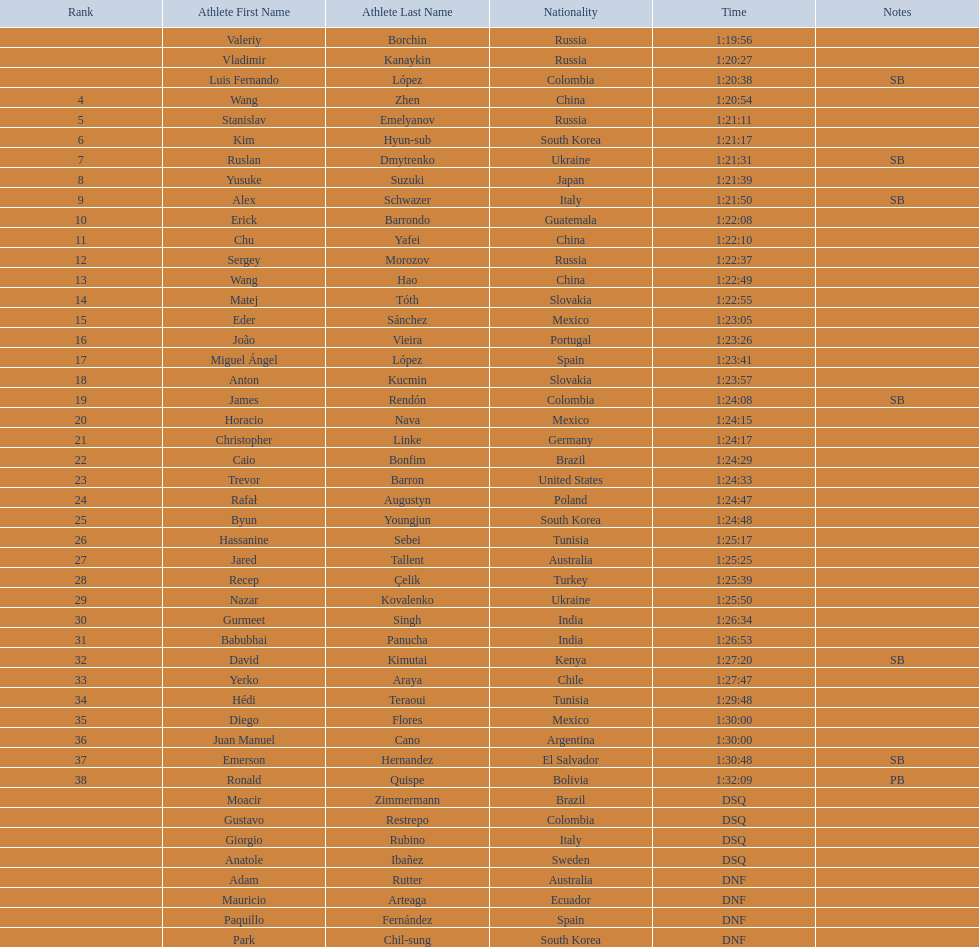Who placed in the top spot? Valeriy Borchin. Would you mind parsing the complete table? {'header': ['Rank', 'Athlete First Name', 'Athlete Last Name', 'Nationality', 'Time', 'Notes'], 'rows': [['', 'Valeriy', 'Borchin', 'Russia', '1:19:56', ''], ['', 'Vladimir', 'Kanaykin', 'Russia', '1:20:27', ''], ['', 'Luis Fernando', 'López', 'Colombia', '1:20:38', 'SB'], ['4', 'Wang', 'Zhen', 'China', '1:20:54', ''], ['5', 'Stanislav', 'Emelyanov', 'Russia', '1:21:11', ''], ['6', 'Kim', 'Hyun-sub', 'South Korea', '1:21:17', ''], ['7', 'Ruslan', 'Dmytrenko', 'Ukraine', '1:21:31', 'SB'], ['8', 'Yusuke', 'Suzuki', 'Japan', '1:21:39', ''], ['9', 'Alex', 'Schwazer', 'Italy', '1:21:50', 'SB'], ['10', 'Erick', 'Barrondo', 'Guatemala', '1:22:08', ''], ['11', 'Chu', 'Yafei', 'China', '1:22:10', ''], ['12', 'Sergey', 'Morozov', 'Russia', '1:22:37', ''], ['13', 'Wang', 'Hao', 'China', '1:22:49', ''], ['14', 'Matej', 'Tóth', 'Slovakia', '1:22:55', ''], ['15', 'Eder', 'Sánchez', 'Mexico', '1:23:05', ''], ['16', 'João', 'Vieira', 'Portugal', '1:23:26', ''], ['17', 'Miguel Ángel', 'López', 'Spain', '1:23:41', ''], ['18', 'Anton', 'Kucmin', 'Slovakia', '1:23:57', ''], ['19', 'James', 'Rendón', 'Colombia', '1:24:08', 'SB'], ['20', 'Horacio', 'Nava', 'Mexico', '1:24:15', ''], ['21', 'Christopher', 'Linke', 'Germany', '1:24:17', ''], ['22', 'Caio', 'Bonfim', 'Brazil', '1:24:29', ''], ['23', 'Trevor', 'Barron', 'United States', '1:24:33', ''], ['24', 'Rafał', 'Augustyn', 'Poland', '1:24:47', ''], ['25', 'Byun', 'Youngjun', 'South Korea', '1:24:48', ''], ['26', 'Hassanine', 'Sebei', 'Tunisia', '1:25:17', ''], ['27', 'Jared', 'Tallent', 'Australia', '1:25:25', ''], ['28', 'Recep', 'Çelik', 'Turkey', '1:25:39', ''], ['29', 'Nazar', 'Kovalenko', 'Ukraine', '1:25:50', ''], ['30', 'Gurmeet', 'Singh', 'India', '1:26:34', ''], ['31', 'Babubhai', 'Panucha', 'India', '1:26:53', ''], ['32', 'David', 'Kimutai', 'Kenya', '1:27:20', 'SB'], ['33', 'Yerko', 'Araya', 'Chile', '1:27:47', ''], ['34', 'Hédi', 'Teraoui', 'Tunisia', '1:29:48', ''], ['35', 'Diego', 'Flores', 'Mexico', '1:30:00', ''], ['36', 'Juan Manuel', 'Cano', 'Argentina', '1:30:00', ''], ['37', 'Emerson', 'Hernandez', 'El Salvador', '1:30:48', 'SB'], ['38', 'Ronald', 'Quispe', 'Bolivia', '1:32:09', 'PB'], ['', 'Moacir', 'Zimmermann', 'Brazil', 'DSQ', ''], ['', 'Gustavo', 'Restrepo', 'Colombia', 'DSQ', ''], ['', 'Giorgio', 'Rubino', 'Italy', 'DSQ', ''], ['', 'Anatole', 'Ibañez', 'Sweden', 'DSQ', ''], ['', 'Adam', 'Rutter', 'Australia', 'DNF', ''], ['', 'Mauricio', 'Arteaga', 'Ecuador', 'DNF', ''], ['', 'Paquillo', 'Fernández', 'Spain', 'DNF', ''], ['', 'Park', 'Chil-sung', 'South Korea', 'DNF', '']]} 